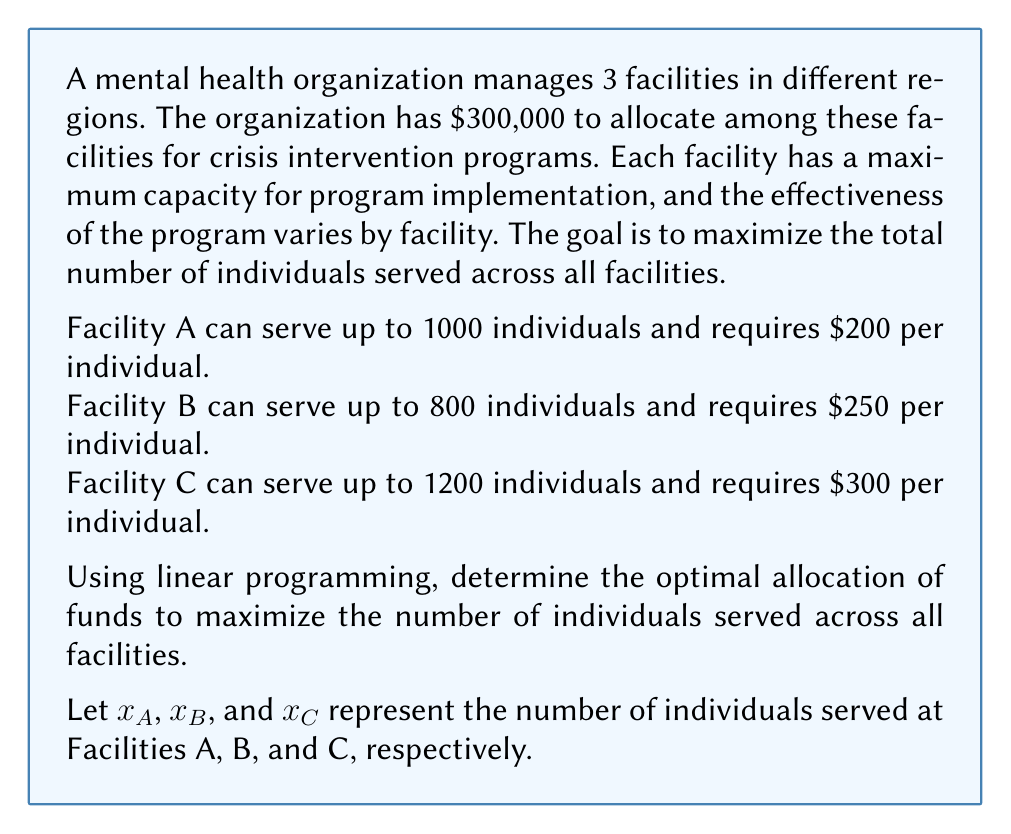Can you answer this question? To solve this problem using linear programming, we need to set up the objective function and constraints:

Objective function (maximize):
$$ Z = x_A + x_B + x_C $$

Constraints:
1. Budget constraint: $200x_A + 250x_B + 300x_C \leq 300000$
2. Capacity constraints:
   $x_A \leq 1000$
   $x_B \leq 800$
   $x_C \leq 1200$
3. Non-negativity constraints:
   $x_A, x_B, x_C \geq 0$

We can solve this using the simplex method or a linear programming solver. However, we can also reason through the solution:

1. Calculate the cost per individual for each facility:
   Facility A: $200 per individual
   Facility B: $250 per individual
   Facility C: $300 per individual

2. To maximize the number of individuals served, we should prioritize facilities with lower costs per individual.

3. Start by allocating funds to Facility A:
   $200 \times 1000 = 200,000$
   This serves 1000 individuals and leaves $100,000.

4. Next, allocate to Facility B:
   $250 \times 400 = 100,000$
   This serves an additional 400 individuals, using the remaining budget.

5. Facility C receives no allocation as it's the most expensive option.

Therefore, the optimal allocation is:
Facility A: 1000 individuals
Facility B: 400 individuals
Facility C: 0 individuals

Total individuals served: 1400
Answer: The optimal allocation to maximize the number of individuals served is:
$x_A = 1000$, $x_B = 400$, $x_C = 0$
Total individuals served: 1400 